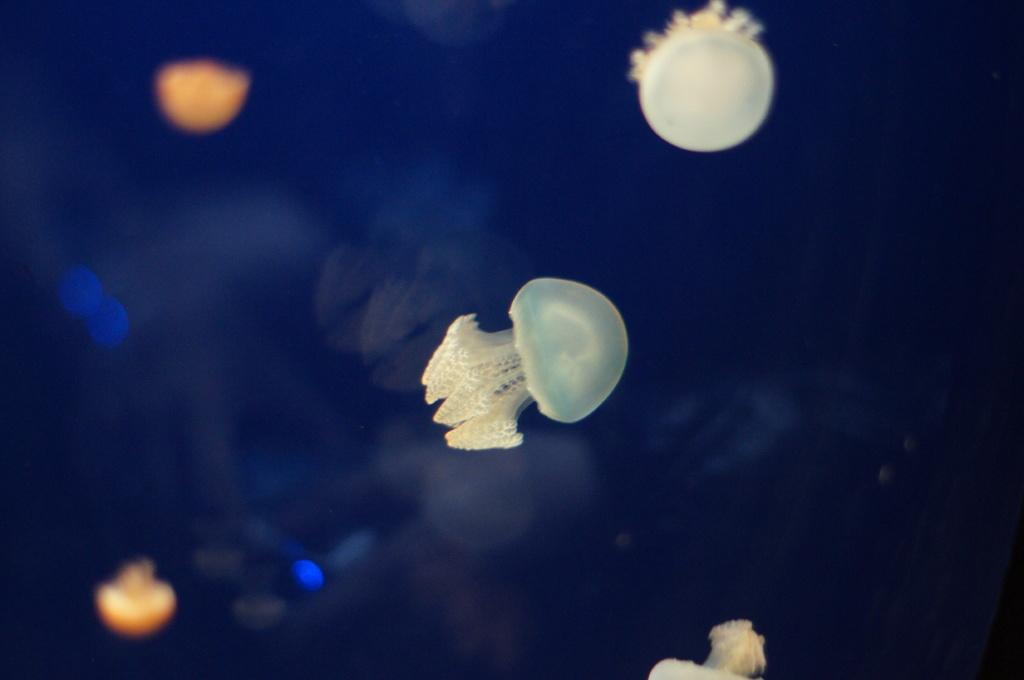What type of sea creatures are in the image? There are jellyfish in the image. What color are the jellyfish? The jellyfish are white in color. What can be observed about the background of the image? The background of the image is dark. What type of bat is flying with the daughter in the image? There is no bat or daughter present in the image; it features white jellyfish against a dark background. 